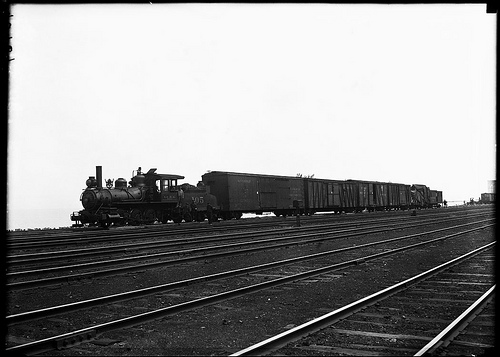<image>What color train is on the track? I don't know the color of the train on the track. It can be black. What color train is on the track? The train on the track is black. 